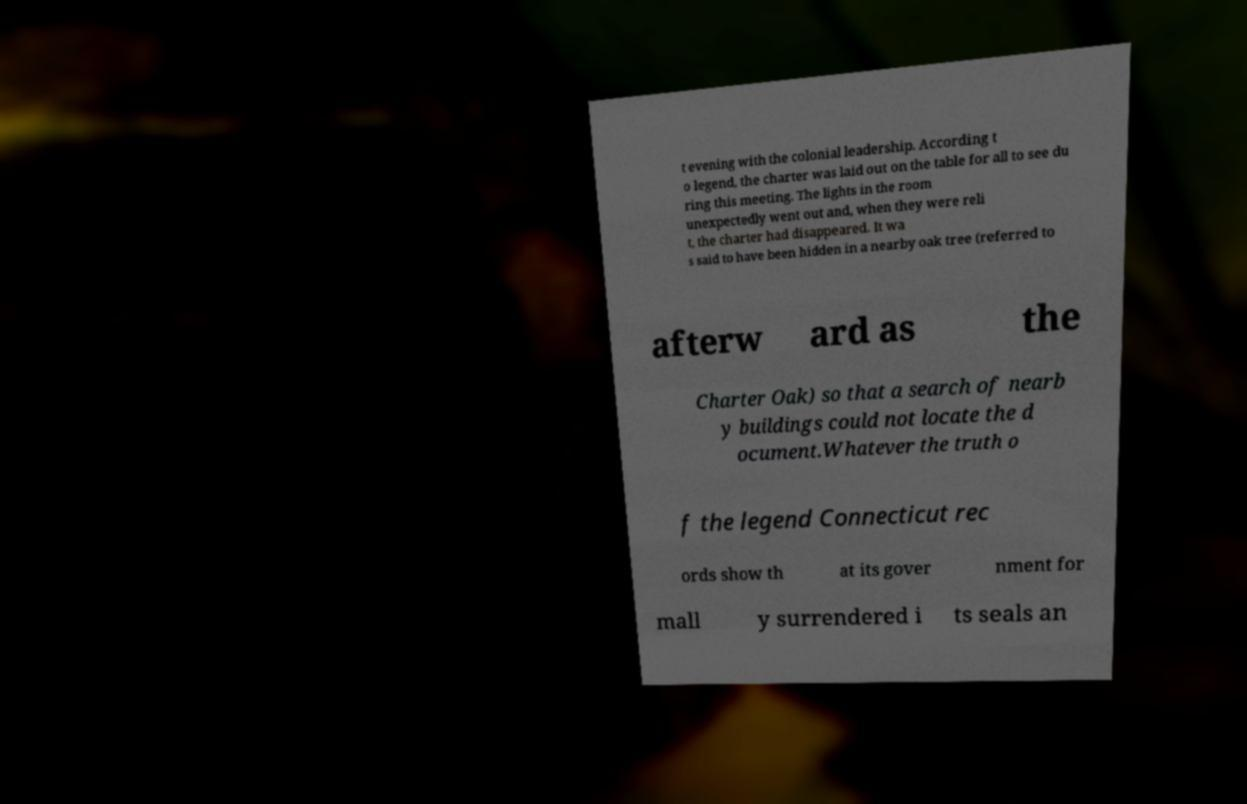Can you read and provide the text displayed in the image?This photo seems to have some interesting text. Can you extract and type it out for me? t evening with the colonial leadership. According t o legend, the charter was laid out on the table for all to see du ring this meeting. The lights in the room unexpectedly went out and, when they were reli t, the charter had disappeared. It wa s said to have been hidden in a nearby oak tree (referred to afterw ard as the Charter Oak) so that a search of nearb y buildings could not locate the d ocument.Whatever the truth o f the legend Connecticut rec ords show th at its gover nment for mall y surrendered i ts seals an 